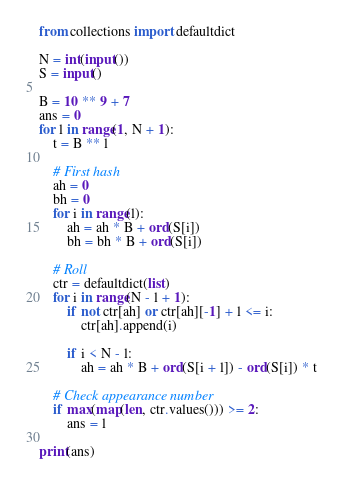Convert code to text. <code><loc_0><loc_0><loc_500><loc_500><_Python_>from collections import defaultdict

N = int(input())
S = input()

B = 10 ** 9 + 7
ans = 0
for l in range(1, N + 1):
    t = B ** l
    
    # First hash
    ah = 0
    bh = 0
    for i in range(l):
        ah = ah * B + ord(S[i])
        bh = bh * B + ord(S[i])
        
    # Roll
    ctr = defaultdict(list)
    for i in range(N - l + 1):
        if not ctr[ah] or ctr[ah][-1] + l <= i:
            ctr[ah].append(i)
        
        if i < N - l:
            ah = ah * B + ord(S[i + l]) - ord(S[i]) * t

    # Check appearance number
    if max(map(len, ctr.values())) >= 2:
        ans = l

print(ans)
</code> 